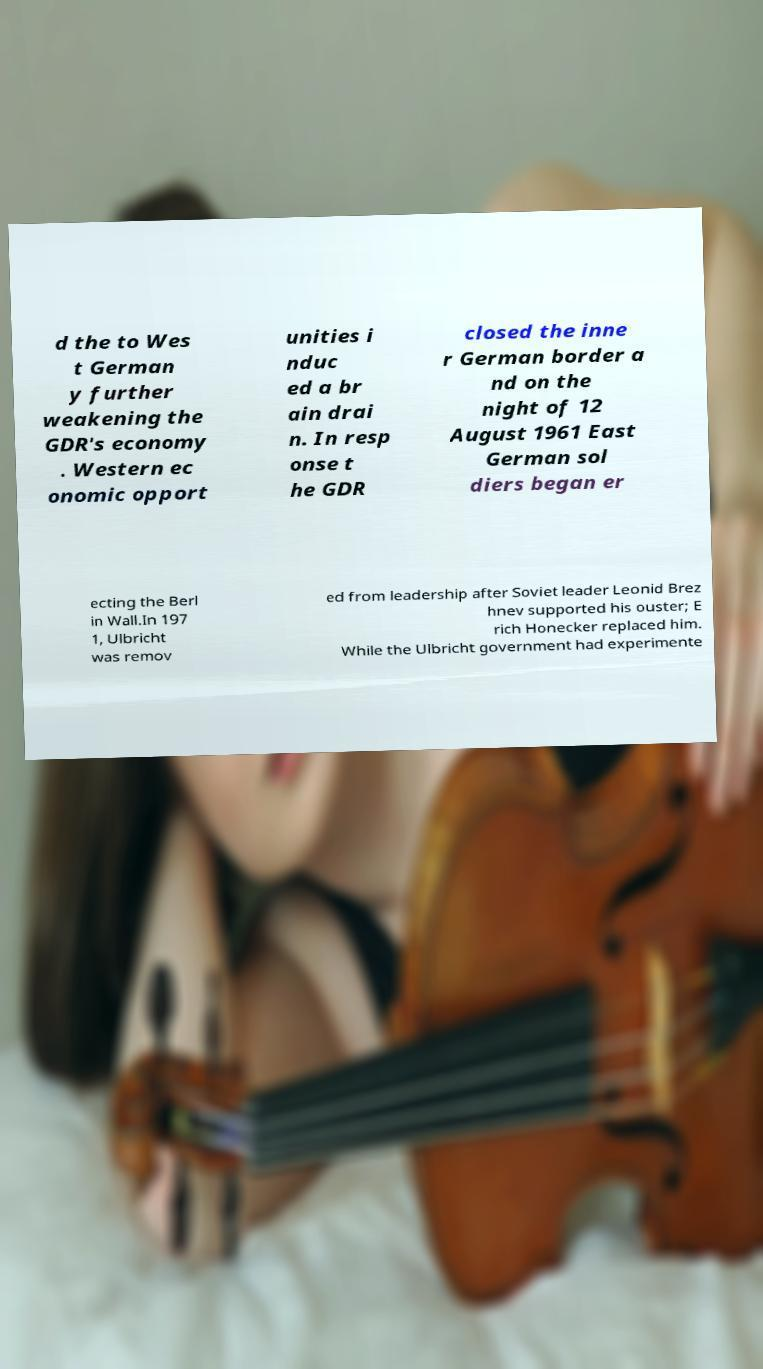Please read and relay the text visible in this image. What does it say? d the to Wes t German y further weakening the GDR's economy . Western ec onomic opport unities i nduc ed a br ain drai n. In resp onse t he GDR closed the inne r German border a nd on the night of 12 August 1961 East German sol diers began er ecting the Berl in Wall.In 197 1, Ulbricht was remov ed from leadership after Soviet leader Leonid Brez hnev supported his ouster; E rich Honecker replaced him. While the Ulbricht government had experimente 